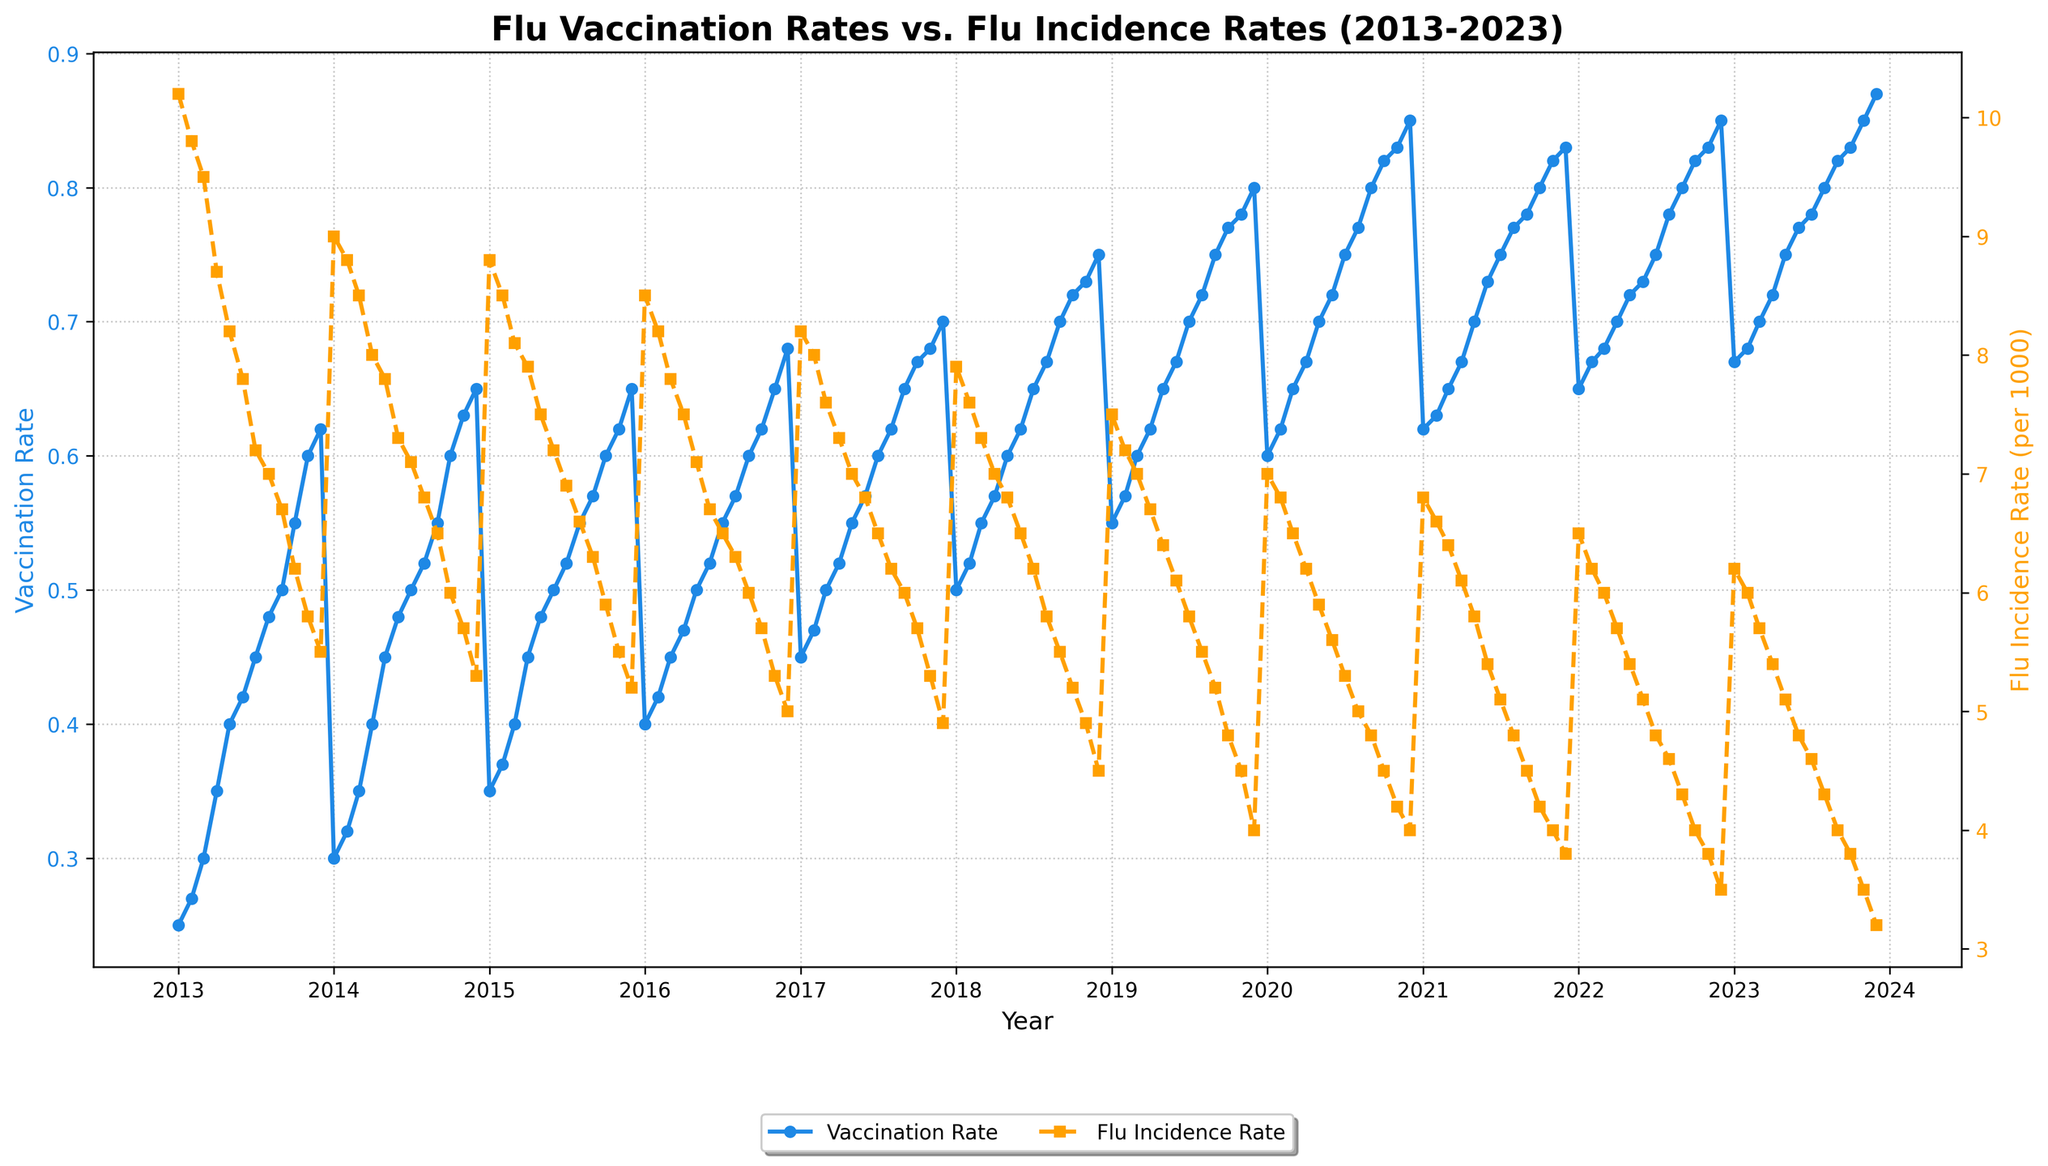What is the title of the graph? The title is usually placed at the top of the figure and is generally the largest piece of text. In this case, the title reads: "Flu Vaccination Rates vs. Flu Incidence Rates (2013-2023)"
Answer: Flu Vaccination Rates vs. Flu Incidence Rates (2013-2023) What color is used to represent the Flu Vaccination Rate line in the plot? The line representing the Flu Vaccination Rate is colored in blue, as indicated by the figure's legend on the graph.
Answer: Blue What are the two y-axes representing in this figure? The figure contains two y-axes, one on the left and one on the right. The left y-axis represents the Flu Vaccination Rate, while the right y-axis represents the Flu Incidence Rate per 1000.
Answer: Flu Vaccination Rate, Flu Incidence Rate per 1000 What can you say about the overall trend of the Flu Incidence Rate from 2013 to 2023? By observing the orange dashed line representing the Flu Incidence Rate, it is clear that the incidence rate has been generally decreasing over the years from 2013 to 2023.
Answer: Decreasing In which year did the Flu Vaccination Rate first exceed 0.60? To find this, observe the blue line representing the Flu Vaccination Rate. The first year it surpasses the 0.60 threshold is 2014.
Answer: 2014 At what month and year was the lowest Flu Incidence Rate observed? Look at the orange dashed line for the Flu Incidence Rate. The lowest value on the graph appears in December 2023.
Answer: December 2023 By how much did the Flu Vaccination Rate increase from January 2013 to December 2023? The Flu Vaccination Rate in January 2013 was 0.25 and in December 2023 it was 0.87. The increase can be found by subtracting the initial value from the final value: 0.87 - 0.25 = 0.62
Answer: 0.62 What is the difference in Flu Incidence Rate between January 2015 and January 2018? The Flu Incidence Rate in January 2015 was 8.8, and in January 2018 it was 7.9. The difference is 8.8 - 7.9 = 0.9
Answer: 0.9 Were there any months over the decade where the Flu Vaccination Rate and Flu Incidence Rate remained constant? By closely observing the plotted lines, there are no points where both the Flu Vaccination Rate and Flu Incidence Rate remain strictly constant over any given month.
Answer: No 